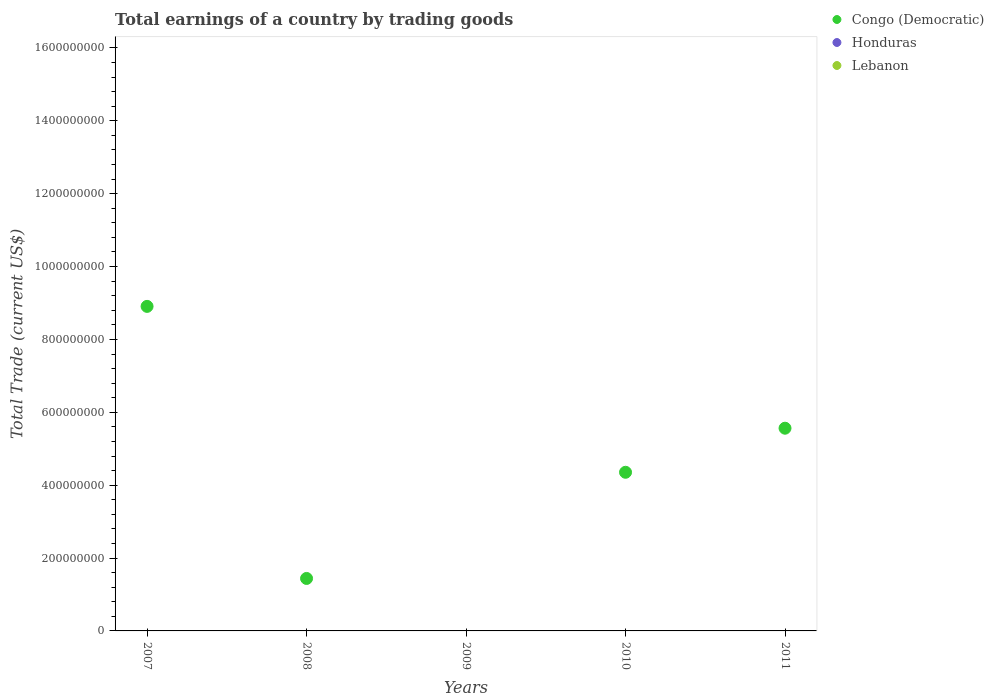Is the number of dotlines equal to the number of legend labels?
Your response must be concise. No. What is the total earnings in Lebanon in 2007?
Your answer should be very brief. 0. Across all years, what is the maximum total earnings in Congo (Democratic)?
Your response must be concise. 8.91e+08. Across all years, what is the minimum total earnings in Congo (Democratic)?
Your response must be concise. 0. What is the total total earnings in Congo (Democratic) in the graph?
Your response must be concise. 2.03e+09. What is the difference between the total earnings in Congo (Democratic) in 2007 and that in 2008?
Provide a succinct answer. 7.47e+08. What is the difference between the total earnings in Lebanon in 2007 and the total earnings in Congo (Democratic) in 2010?
Your response must be concise. -4.35e+08. What is the average total earnings in Lebanon per year?
Ensure brevity in your answer.  0. In how many years, is the total earnings in Lebanon greater than 920000000 US$?
Your answer should be compact. 0. What is the ratio of the total earnings in Congo (Democratic) in 2008 to that in 2011?
Keep it short and to the point. 0.26. What is the difference between the highest and the second highest total earnings in Congo (Democratic)?
Your answer should be very brief. 3.34e+08. What is the difference between the highest and the lowest total earnings in Congo (Democratic)?
Ensure brevity in your answer.  8.91e+08. In how many years, is the total earnings in Honduras greater than the average total earnings in Honduras taken over all years?
Provide a succinct answer. 0. Is the total earnings in Lebanon strictly greater than the total earnings in Honduras over the years?
Give a very brief answer. No. How many dotlines are there?
Your response must be concise. 1. What is the difference between two consecutive major ticks on the Y-axis?
Your answer should be compact. 2.00e+08. Are the values on the major ticks of Y-axis written in scientific E-notation?
Provide a short and direct response. No. Does the graph contain any zero values?
Provide a succinct answer. Yes. Where does the legend appear in the graph?
Offer a terse response. Top right. How many legend labels are there?
Provide a succinct answer. 3. What is the title of the graph?
Ensure brevity in your answer.  Total earnings of a country by trading goods. Does "Tunisia" appear as one of the legend labels in the graph?
Make the answer very short. No. What is the label or title of the X-axis?
Offer a very short reply. Years. What is the label or title of the Y-axis?
Ensure brevity in your answer.  Total Trade (current US$). What is the Total Trade (current US$) in Congo (Democratic) in 2007?
Your answer should be compact. 8.91e+08. What is the Total Trade (current US$) of Honduras in 2007?
Make the answer very short. 0. What is the Total Trade (current US$) in Congo (Democratic) in 2008?
Make the answer very short. 1.44e+08. What is the Total Trade (current US$) of Honduras in 2009?
Provide a succinct answer. 0. What is the Total Trade (current US$) in Congo (Democratic) in 2010?
Keep it short and to the point. 4.35e+08. What is the Total Trade (current US$) of Honduras in 2010?
Your response must be concise. 0. What is the Total Trade (current US$) in Lebanon in 2010?
Keep it short and to the point. 0. What is the Total Trade (current US$) of Congo (Democratic) in 2011?
Offer a very short reply. 5.56e+08. What is the Total Trade (current US$) in Lebanon in 2011?
Offer a terse response. 0. Across all years, what is the maximum Total Trade (current US$) in Congo (Democratic)?
Provide a short and direct response. 8.91e+08. Across all years, what is the minimum Total Trade (current US$) of Congo (Democratic)?
Give a very brief answer. 0. What is the total Total Trade (current US$) of Congo (Democratic) in the graph?
Ensure brevity in your answer.  2.03e+09. What is the difference between the Total Trade (current US$) in Congo (Democratic) in 2007 and that in 2008?
Give a very brief answer. 7.47e+08. What is the difference between the Total Trade (current US$) of Congo (Democratic) in 2007 and that in 2010?
Offer a terse response. 4.55e+08. What is the difference between the Total Trade (current US$) in Congo (Democratic) in 2007 and that in 2011?
Provide a short and direct response. 3.34e+08. What is the difference between the Total Trade (current US$) of Congo (Democratic) in 2008 and that in 2010?
Your response must be concise. -2.91e+08. What is the difference between the Total Trade (current US$) in Congo (Democratic) in 2008 and that in 2011?
Offer a terse response. -4.12e+08. What is the difference between the Total Trade (current US$) in Congo (Democratic) in 2010 and that in 2011?
Your answer should be compact. -1.21e+08. What is the average Total Trade (current US$) in Congo (Democratic) per year?
Provide a short and direct response. 4.05e+08. What is the average Total Trade (current US$) of Lebanon per year?
Your answer should be compact. 0. What is the ratio of the Total Trade (current US$) in Congo (Democratic) in 2007 to that in 2008?
Provide a short and direct response. 6.19. What is the ratio of the Total Trade (current US$) of Congo (Democratic) in 2007 to that in 2010?
Keep it short and to the point. 2.05. What is the ratio of the Total Trade (current US$) in Congo (Democratic) in 2007 to that in 2011?
Make the answer very short. 1.6. What is the ratio of the Total Trade (current US$) in Congo (Democratic) in 2008 to that in 2010?
Your answer should be very brief. 0.33. What is the ratio of the Total Trade (current US$) in Congo (Democratic) in 2008 to that in 2011?
Offer a terse response. 0.26. What is the ratio of the Total Trade (current US$) of Congo (Democratic) in 2010 to that in 2011?
Make the answer very short. 0.78. What is the difference between the highest and the second highest Total Trade (current US$) in Congo (Democratic)?
Provide a succinct answer. 3.34e+08. What is the difference between the highest and the lowest Total Trade (current US$) in Congo (Democratic)?
Provide a succinct answer. 8.91e+08. 